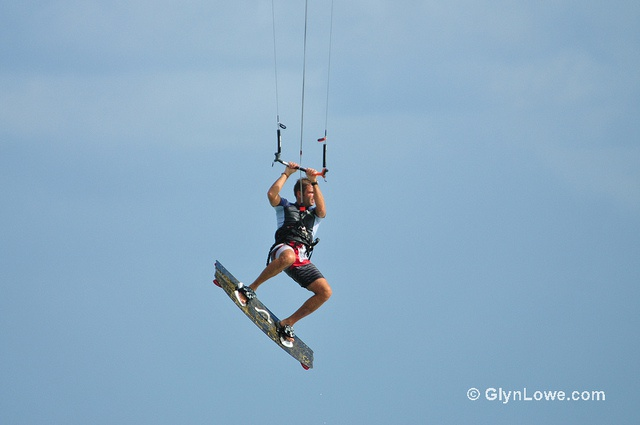Describe the objects in this image and their specific colors. I can see people in darkgray, black, maroon, and gray tones and surfboard in darkgray, gray, black, darkgreen, and white tones in this image. 